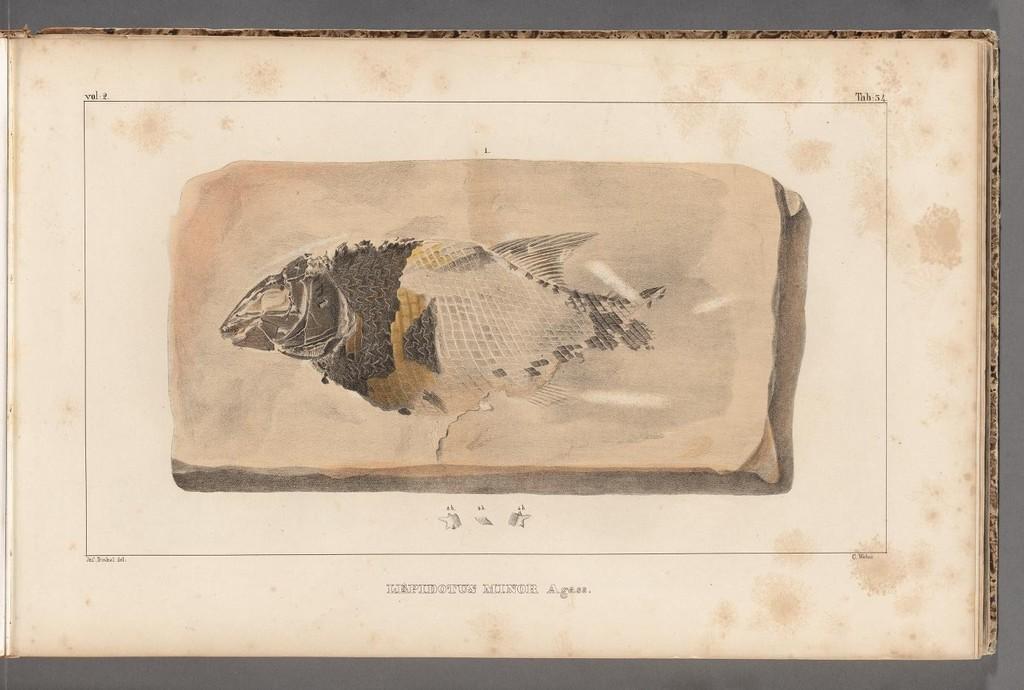How would you summarize this image in a sentence or two? In the image there is a part of a fish on a paper. 